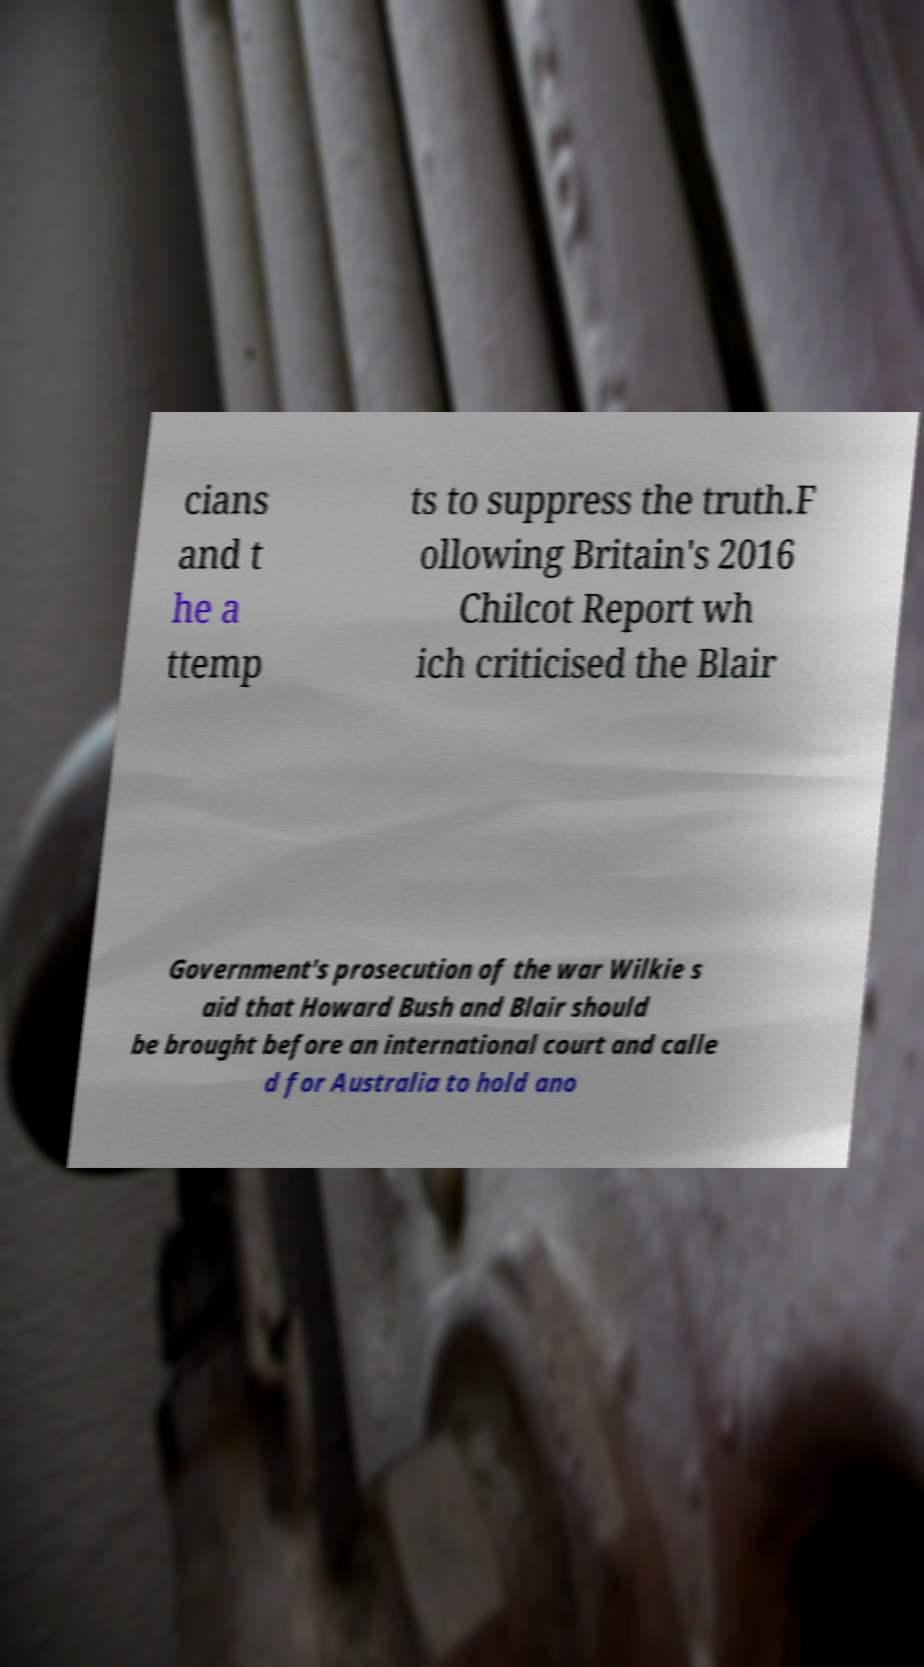For documentation purposes, I need the text within this image transcribed. Could you provide that? cians and t he a ttemp ts to suppress the truth.F ollowing Britain's 2016 Chilcot Report wh ich criticised the Blair Government's prosecution of the war Wilkie s aid that Howard Bush and Blair should be brought before an international court and calle d for Australia to hold ano 